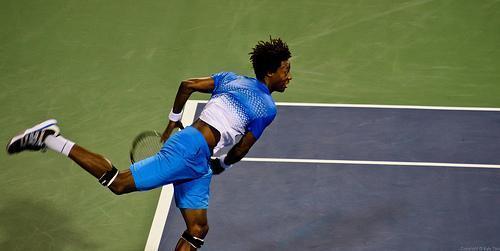How many people are in the image?
Give a very brief answer. 1. How many feet does the player have on the ground?
Give a very brief answer. 1. 